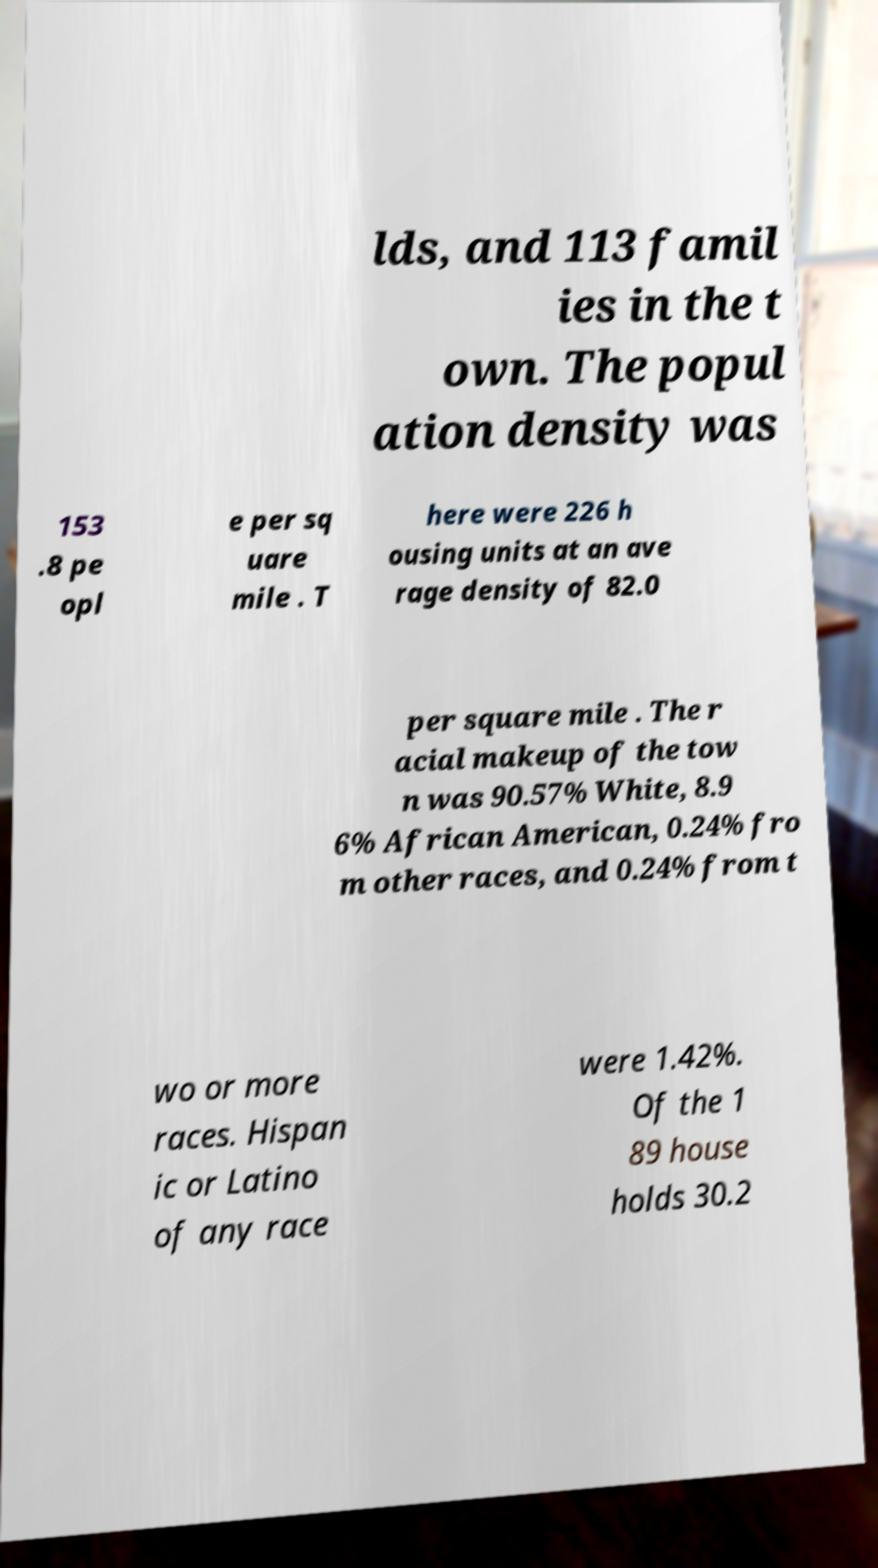For documentation purposes, I need the text within this image transcribed. Could you provide that? lds, and 113 famil ies in the t own. The popul ation density was 153 .8 pe opl e per sq uare mile . T here were 226 h ousing units at an ave rage density of 82.0 per square mile . The r acial makeup of the tow n was 90.57% White, 8.9 6% African American, 0.24% fro m other races, and 0.24% from t wo or more races. Hispan ic or Latino of any race were 1.42%. Of the 1 89 house holds 30.2 